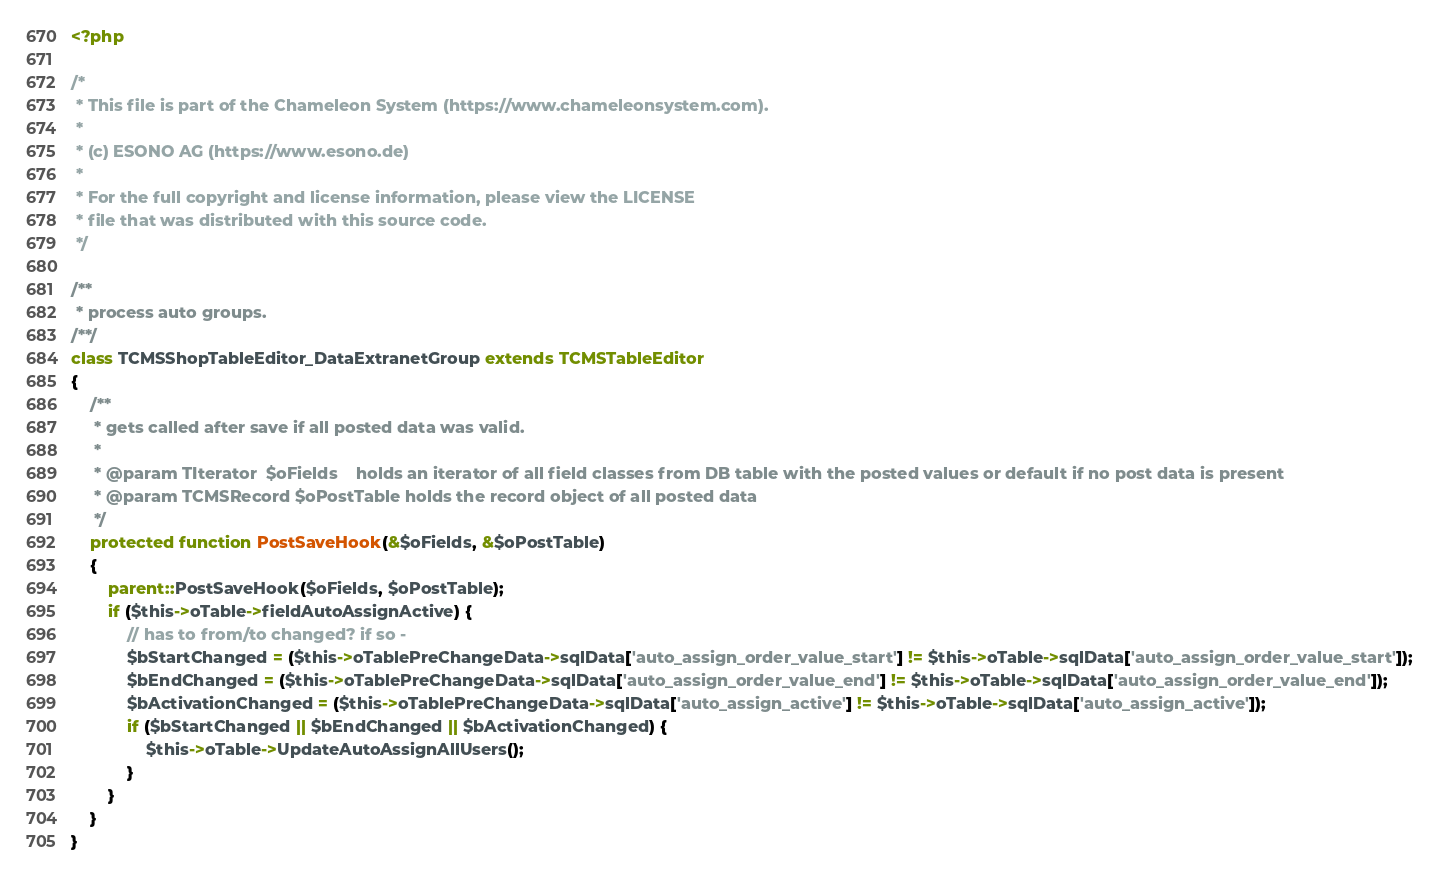<code> <loc_0><loc_0><loc_500><loc_500><_PHP_><?php

/*
 * This file is part of the Chameleon System (https://www.chameleonsystem.com).
 *
 * (c) ESONO AG (https://www.esono.de)
 *
 * For the full copyright and license information, please view the LICENSE
 * file that was distributed with this source code.
 */

/**
 * process auto groups.
/**/
class TCMSShopTableEditor_DataExtranetGroup extends TCMSTableEditor
{
    /**
     * gets called after save if all posted data was valid.
     *
     * @param TIterator  $oFields    holds an iterator of all field classes from DB table with the posted values or default if no post data is present
     * @param TCMSRecord $oPostTable holds the record object of all posted data
     */
    protected function PostSaveHook(&$oFields, &$oPostTable)
    {
        parent::PostSaveHook($oFields, $oPostTable);
        if ($this->oTable->fieldAutoAssignActive) {
            // has to from/to changed? if so -
            $bStartChanged = ($this->oTablePreChangeData->sqlData['auto_assign_order_value_start'] != $this->oTable->sqlData['auto_assign_order_value_start']);
            $bEndChanged = ($this->oTablePreChangeData->sqlData['auto_assign_order_value_end'] != $this->oTable->sqlData['auto_assign_order_value_end']);
            $bActivationChanged = ($this->oTablePreChangeData->sqlData['auto_assign_active'] != $this->oTable->sqlData['auto_assign_active']);
            if ($bStartChanged || $bEndChanged || $bActivationChanged) {
                $this->oTable->UpdateAutoAssignAllUsers();
            }
        }
    }
}
</code> 